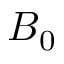<formula> <loc_0><loc_0><loc_500><loc_500>B _ { 0 }</formula> 